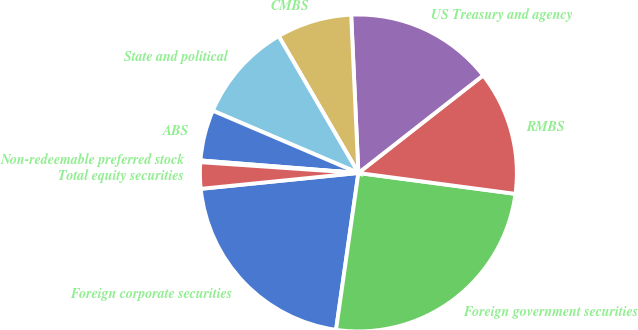<chart> <loc_0><loc_0><loc_500><loc_500><pie_chart><fcel>Foreign corporate securities<fcel>Foreign government securities<fcel>RMBS<fcel>US Treasury and agency<fcel>CMBS<fcel>State and political<fcel>ABS<fcel>Non-redeemable preferred stock<fcel>Total equity securities<nl><fcel>21.15%<fcel>25.15%<fcel>12.67%<fcel>15.16%<fcel>7.67%<fcel>10.17%<fcel>5.17%<fcel>0.18%<fcel>2.68%<nl></chart> 